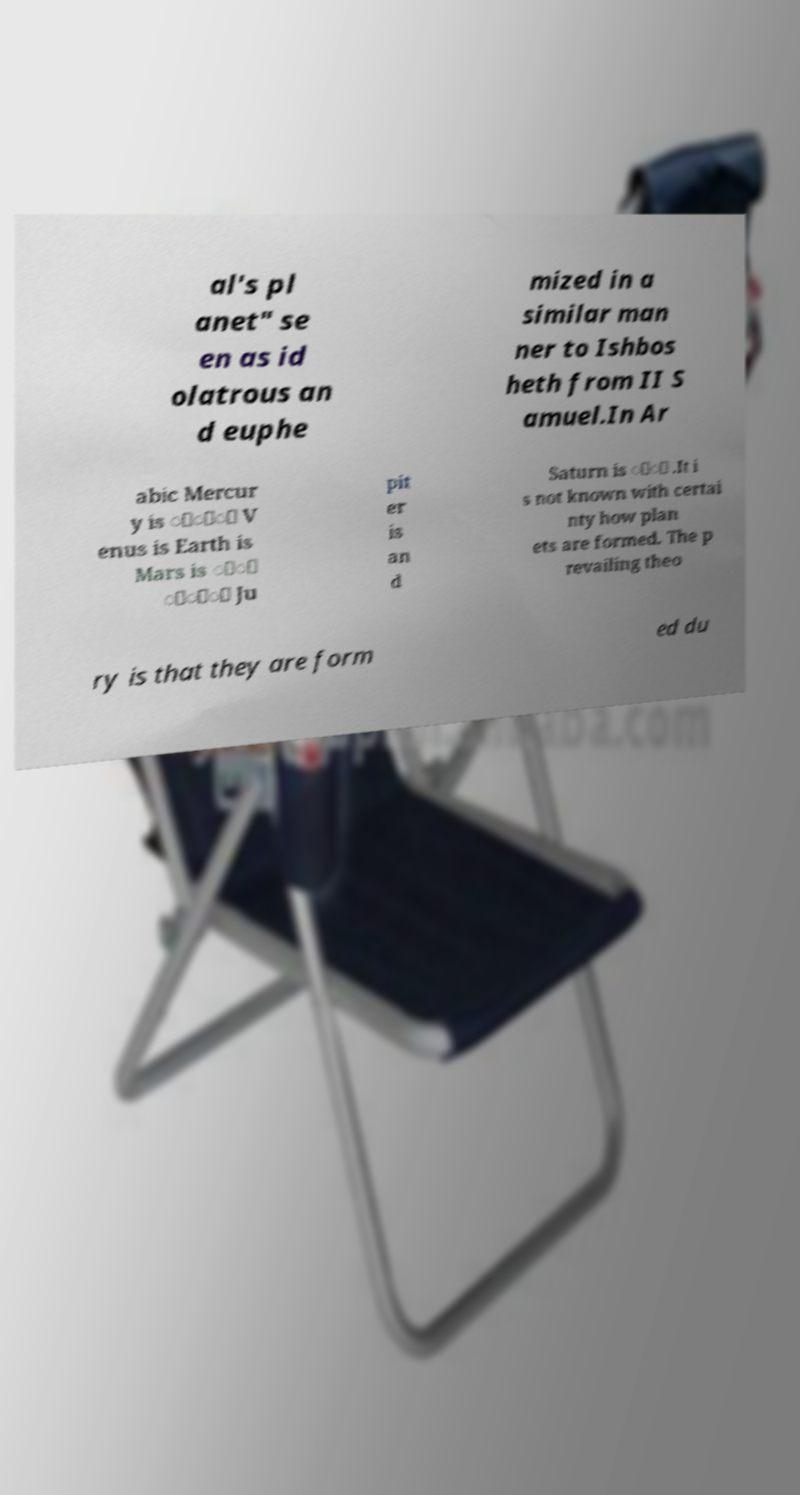For documentation purposes, I need the text within this image transcribed. Could you provide that? al's pl anet" se en as id olatrous an d euphe mized in a similar man ner to Ishbos heth from II S amuel.In Ar abic Mercur y is َُِ V enus is Earth is Mars is َْ ِِّ Ju pit er is an d Saturn is َُ .It i s not known with certai nty how plan ets are formed. The p revailing theo ry is that they are form ed du 